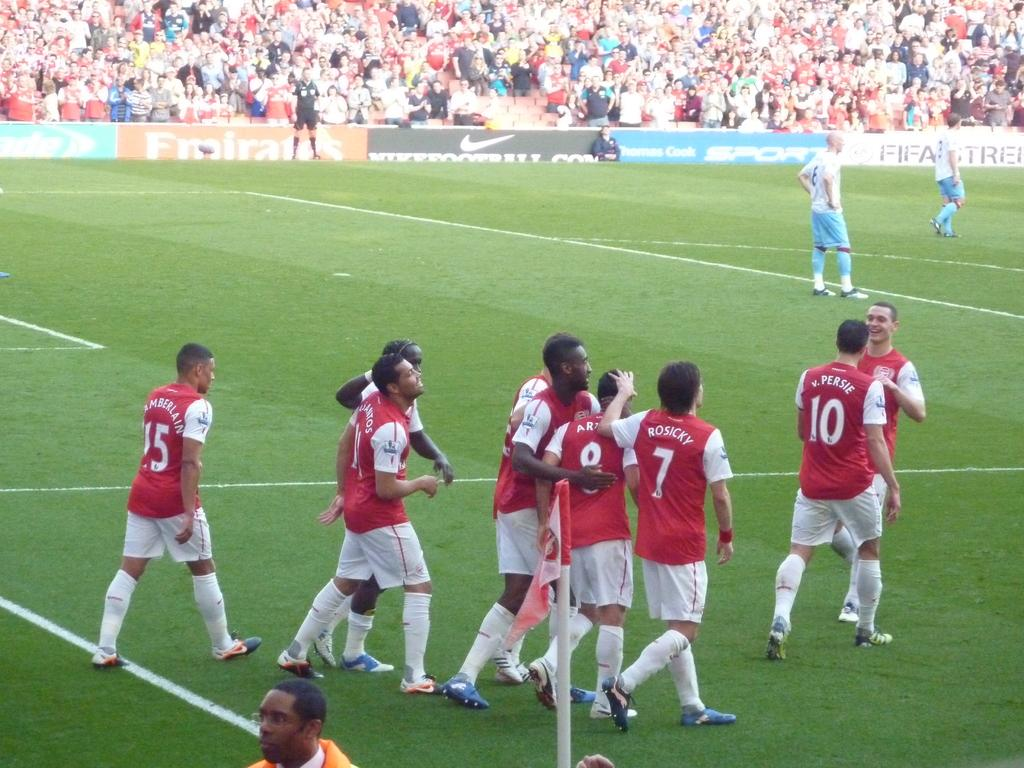<image>
Provide a brief description of the given image. The soccer team is shown on FIFA streaming as advertised. 